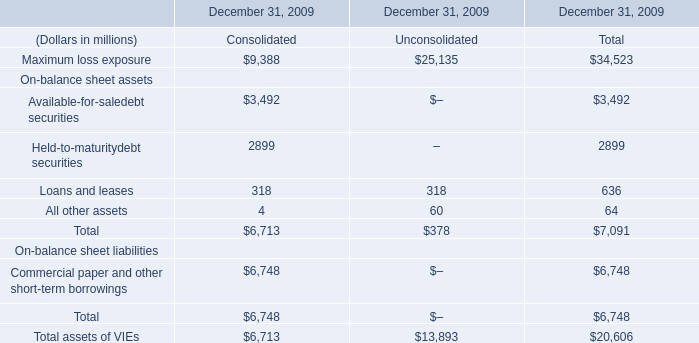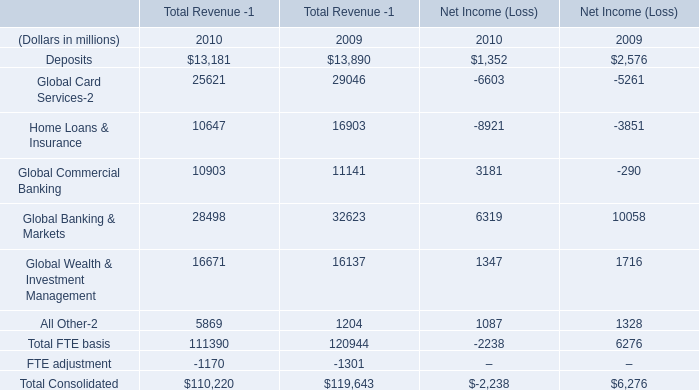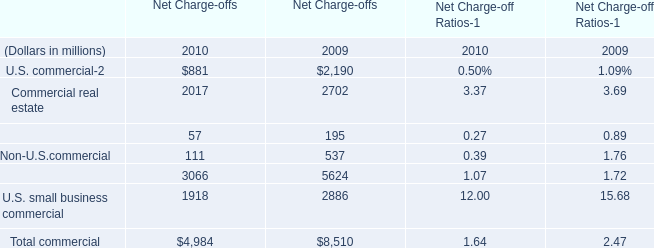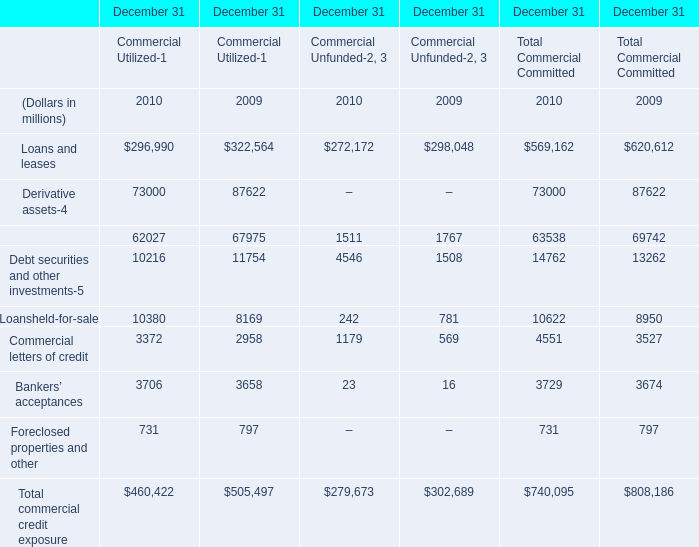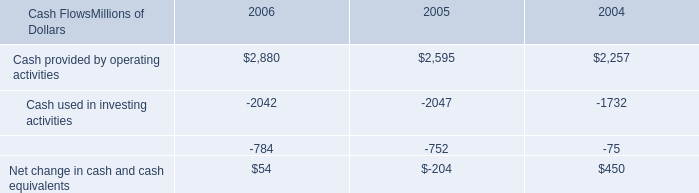what was the percentage change in cash provided by operating activities between 2004 and 2005? 
Computations: ((2595 - 2257) / 2257)
Answer: 0.14976. 